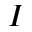<formula> <loc_0><loc_0><loc_500><loc_500>I</formula> 